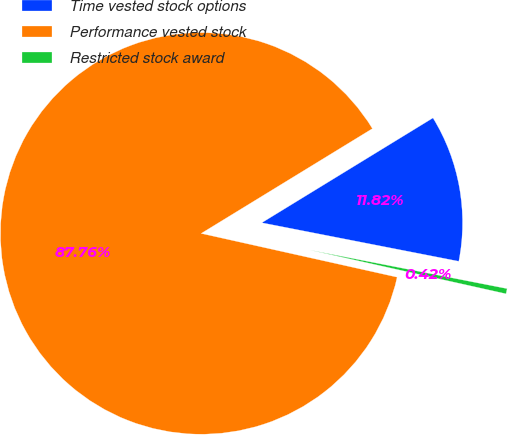Convert chart to OTSL. <chart><loc_0><loc_0><loc_500><loc_500><pie_chart><fcel>Time vested stock options<fcel>Performance vested stock<fcel>Restricted stock award<nl><fcel>11.82%<fcel>87.77%<fcel>0.42%<nl></chart> 